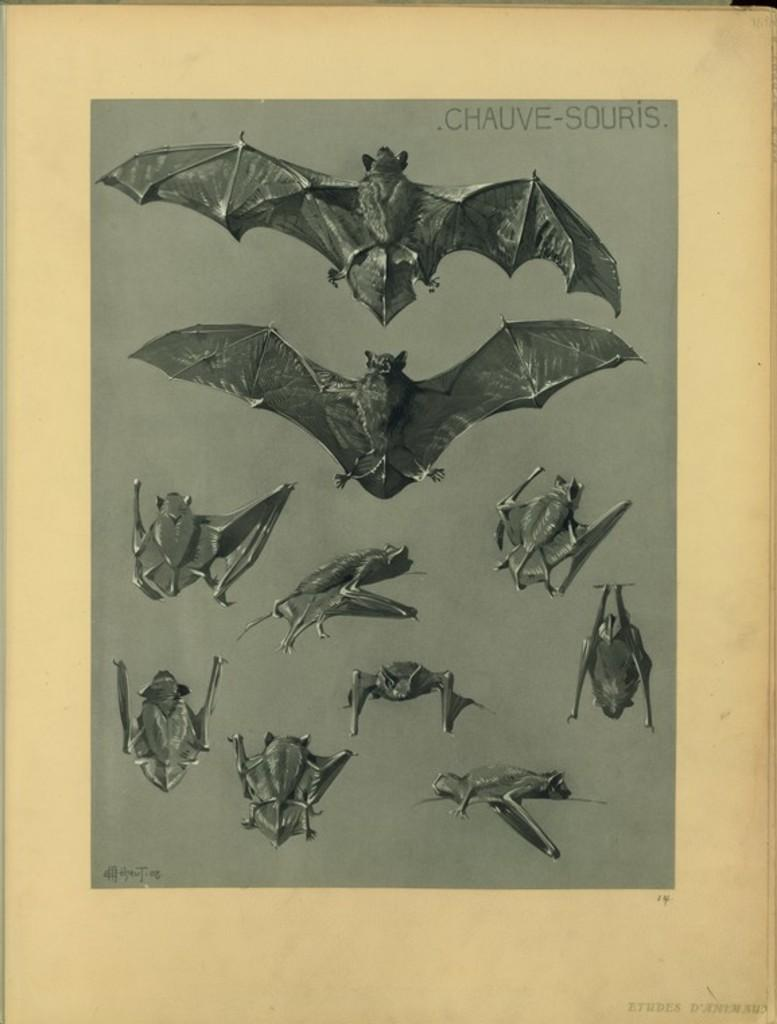What type of image is being described? The image appears to be an art piece. What is the main subject of the art piece? There are many bats depicted in the art piece. How many apples are being held by the turkey in the image? There is no turkey or apple present in the image; it features an art piece with many bats. 